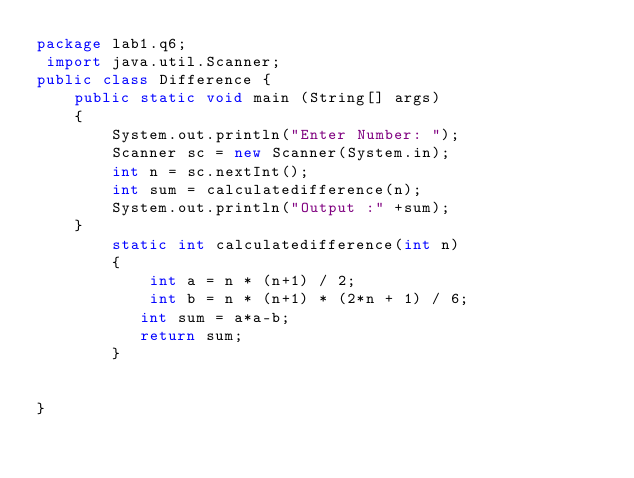Convert code to text. <code><loc_0><loc_0><loc_500><loc_500><_Java_>package lab1.q6;
 import java.util.Scanner;
public class Difference {
	public static void main (String[] args) 
	{
		System.out.println("Enter Number: ");
		Scanner sc = new Scanner(System.in);
		int n = sc.nextInt();
		int sum = calculatedifference(n);
		System.out.println("Output :" +sum);
	}
	    static int calculatedifference(int n)
	    {
	        int a = n * (n+1) / 2;
	        int b = n * (n+1) * (2*n + 1) / 6;
	       int sum = a*a-b;
	       return sum;
	    }


}
</code> 